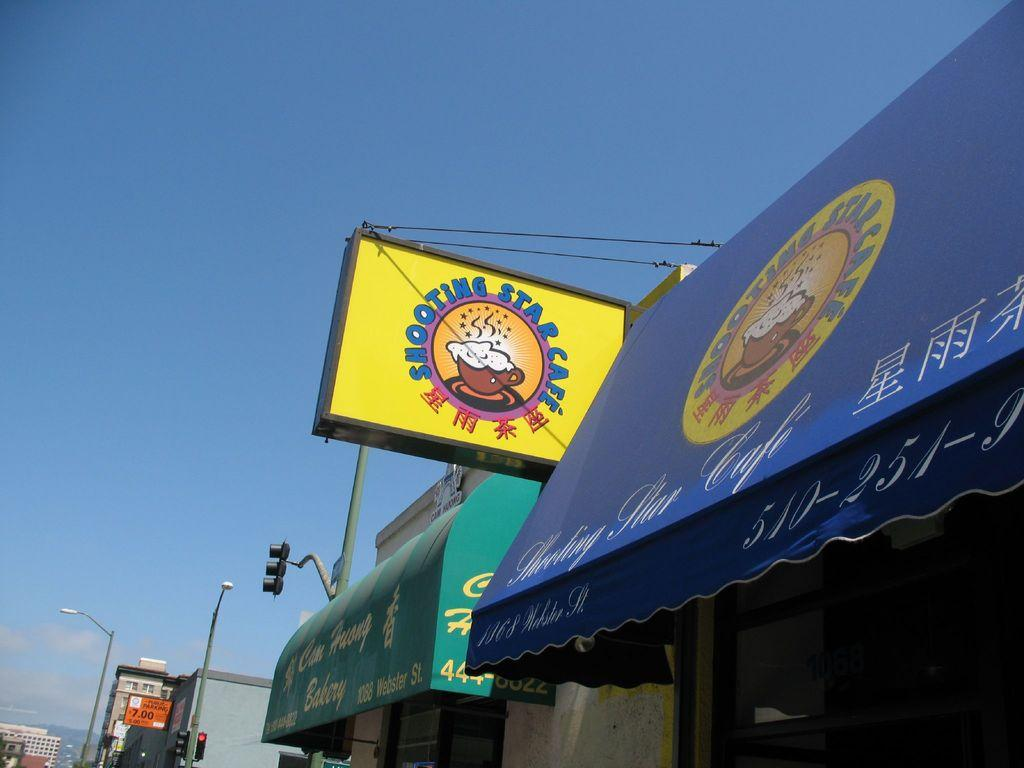<image>
Render a clear and concise summary of the photo. The sign for the shooting star cafe has English and Asian script on the sign. 